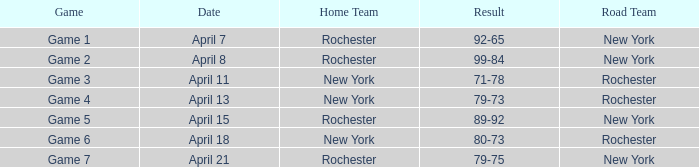Which Result has a Home Team of rochester, and a Game of game 5? 89-92. 